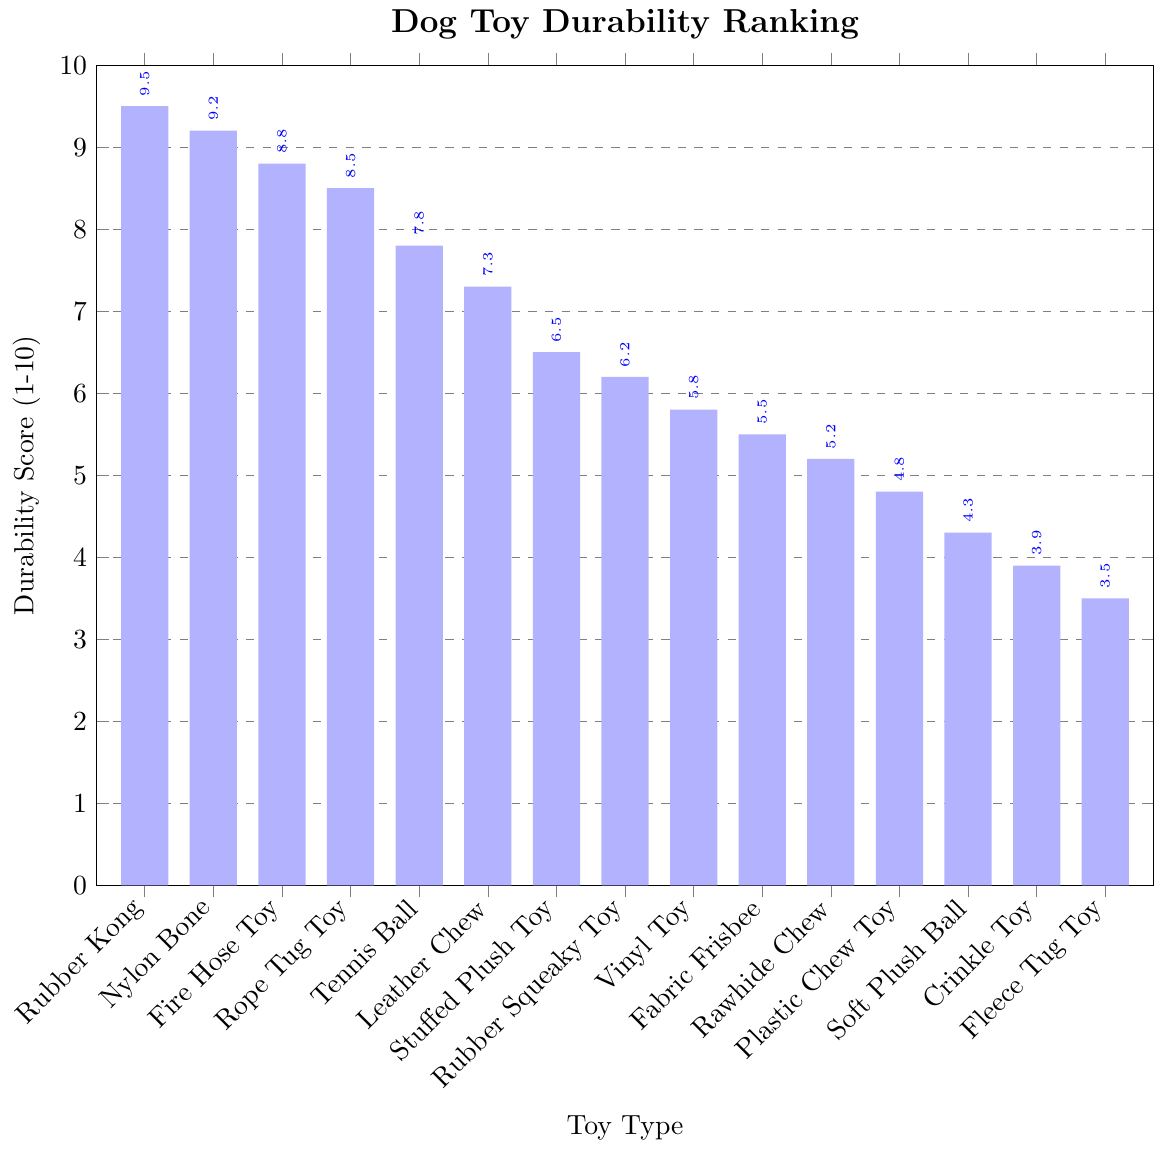What type of toy has the highest durability score? The bar representing the Rubber Kong toy is the tallest and reaches the highest value on the y-axis, which is 9.5, indicating it has the highest durability score.
Answer: Rubber Kong Which toy has a higher durability score, Leather Chew or Tennis Ball? By comparing the heights of the bars for Leather Chew and Tennis Ball, it is evident that the Tennis Ball bar is taller than that of Leather Chew. The durability score for Tennis Ball is 7.8, and for Leather Chew, it is 7.3.
Answer: Tennis Ball What's the total durability score for Nylon Bone and Rope Tug Toy combined? The durability score for Nylon Bone is 9.2 and for Rope Tug Toy it is 8.5. Adding these together: 9.2 + 8.5 = 17.7.
Answer: 17.7 Which toy is less durable, Soft Plush Ball or Crinkle Toy? Comparing the heights of the bars for Soft Plush Ball and Crinkle Toy, the Soft Plush Ball has a score of 4.3, and Crinkle Toy has a score of 3.9. Since 3.9 is less than 4.3, Crinkle Toy is less durable.
Answer: Crinkle Toy What is the durability score difference between the Rubber Kong and Plastic Chew Toy? The durability score for Rubber Kong is 9.5, and for Plastic Chew Toy, it is 4.8. Subtracting these: 9.5 - 4.8 = 4.7.
Answer: 4.7 Which type of toy has the lowest durability score? The shortest bar belongs to the Fleece Tug Toy, which has the lowest durability score of 3.5.
Answer: Fleece Tug Toy How many toys have a durability score greater than 8? The bars that exceed the 8 mark on the y-axis belong to Rubber Kong, Nylon Bone, Fire Hose Toy, and Rope Tug Toy. Counting these, there are 4 toys.
Answer: 4 What is the average durability score of the top three toys? The top three toys are Rubber Kong (9.5), Nylon Bone (9.2), and Fire Hose Toy (8.8). Summing the scores: 9.5 + 9.2 + 8.8 = 27.5. Dividing by 3: 27.5 / 3 = 9.17.
Answer: 9.17 Is the durability score of the Rope Tug Toy closer to the Nylon Bone or the Tennis Ball? Rope Tug Toy has a score of 8.5. Comparing to Nylon Bone (9.2), the difference is 9.2 - 8.5 = 0.7. Comparing to Tennis Ball (7.8), the difference is 8.5 - 7.8 = 0.7. Both differences are equal, so it is equally close to both.
Answer: Equally close to both 